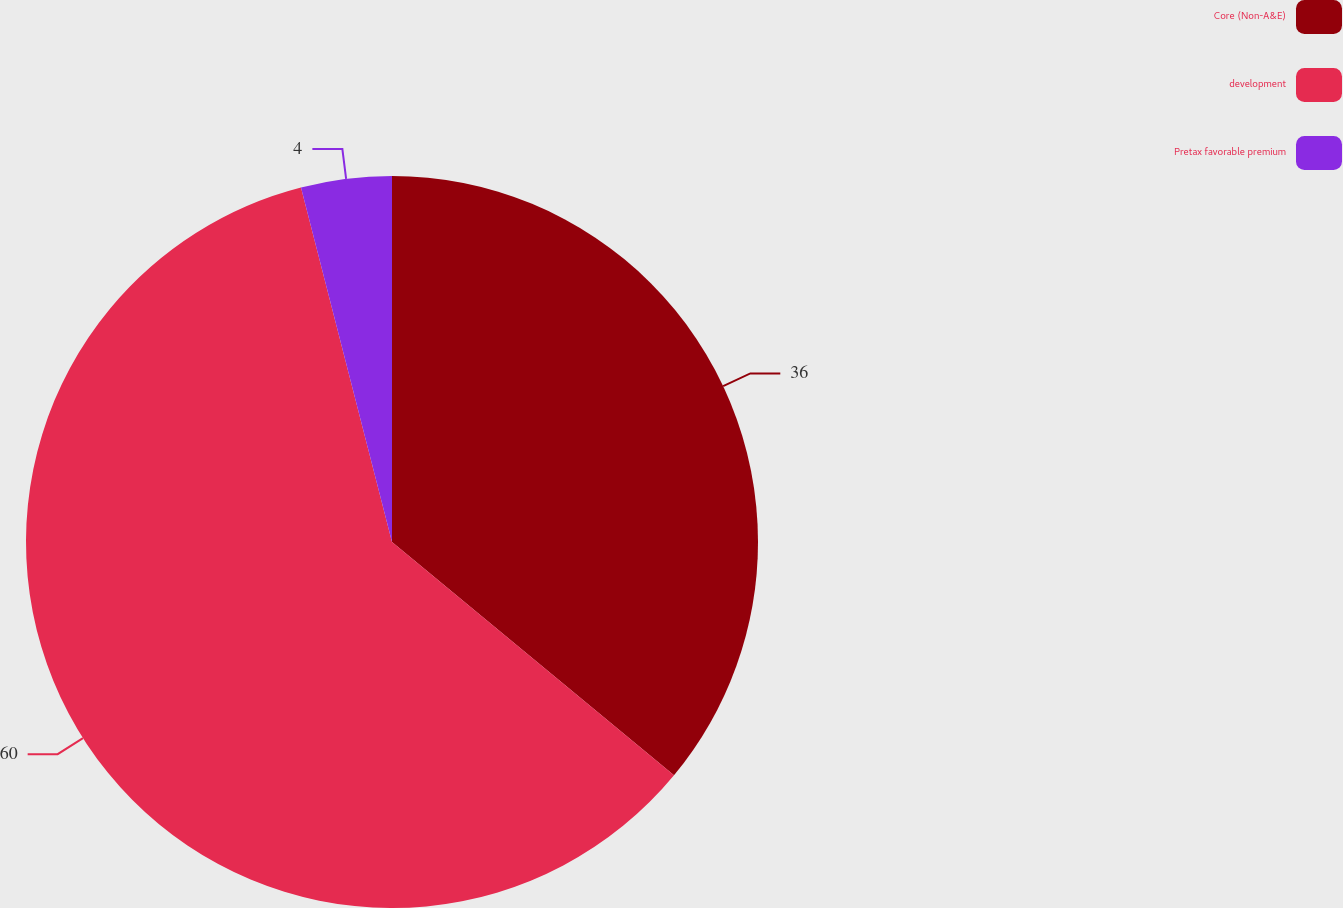Convert chart. <chart><loc_0><loc_0><loc_500><loc_500><pie_chart><fcel>Core (Non-A&E)<fcel>development<fcel>Pretax favorable premium<nl><fcel>36.0%<fcel>60.0%<fcel>4.0%<nl></chart> 